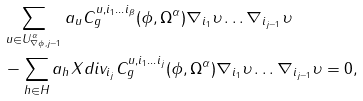<formula> <loc_0><loc_0><loc_500><loc_500>& \sum _ { u \in U ^ { \alpha } _ { \nabla \phi , j - 1 } } a _ { u } C ^ { u , i _ { 1 } \dots i _ { \beta } } _ { g } ( \phi , \Omega ^ { \alpha } ) \nabla _ { i _ { 1 } } \upsilon \dots \nabla _ { i _ { j - 1 } } \upsilon \\ & - \sum _ { h \in H } a _ { h } X d i v _ { i _ { j } } C ^ { u , i _ { 1 } \dots i _ { j } } _ { g } ( \phi , \Omega ^ { \alpha } ) \nabla _ { i _ { 1 } } \upsilon \dots \nabla _ { i _ { j - 1 } } \upsilon = 0 ,</formula> 